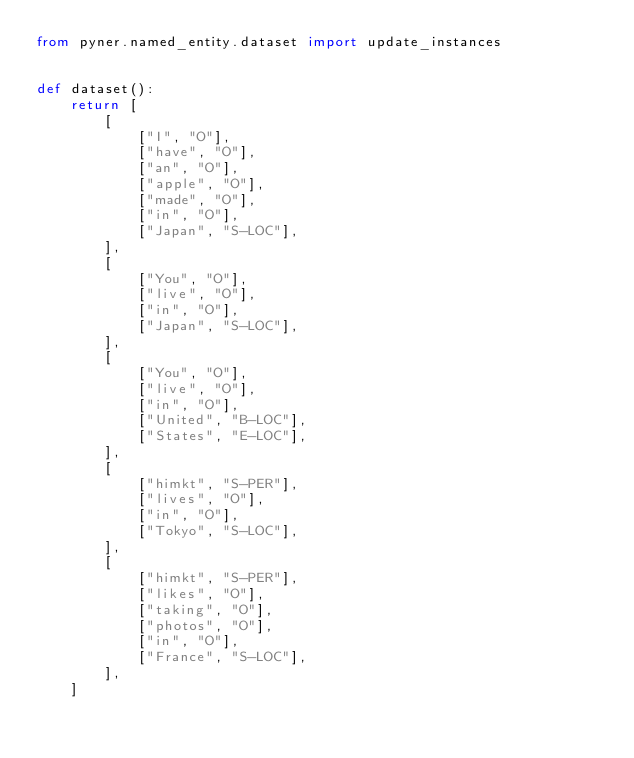Convert code to text. <code><loc_0><loc_0><loc_500><loc_500><_Python_>from pyner.named_entity.dataset import update_instances


def dataset():
    return [
        [
            ["I", "O"],
            ["have", "O"],
            ["an", "O"],
            ["apple", "O"],
            ["made", "O"],
            ["in", "O"],
            ["Japan", "S-LOC"],
        ],
        [
            ["You", "O"],
            ["live", "O"],
            ["in", "O"],
            ["Japan", "S-LOC"],
        ],
        [
            ["You", "O"],
            ["live", "O"],
            ["in", "O"],
            ["United", "B-LOC"],
            ["States", "E-LOC"],
        ],
        [
            ["himkt", "S-PER"],
            ["lives", "O"],
            ["in", "O"],
            ["Tokyo", "S-LOC"],
        ],
        [
            ["himkt", "S-PER"],
            ["likes", "O"],
            ["taking", "O"],
            ["photos", "O"],
            ["in", "O"],
            ["France", "S-LOC"],
        ],
    ]

</code> 